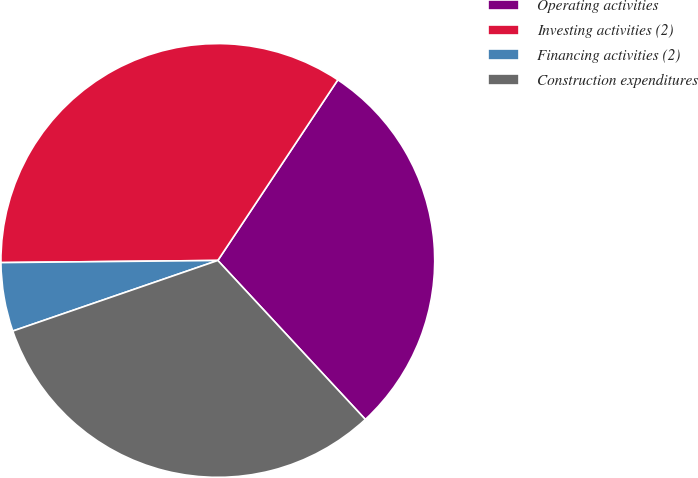<chart> <loc_0><loc_0><loc_500><loc_500><pie_chart><fcel>Operating activities<fcel>Investing activities (2)<fcel>Financing activities (2)<fcel>Construction expenditures<nl><fcel>28.76%<fcel>34.49%<fcel>5.12%<fcel>31.63%<nl></chart> 